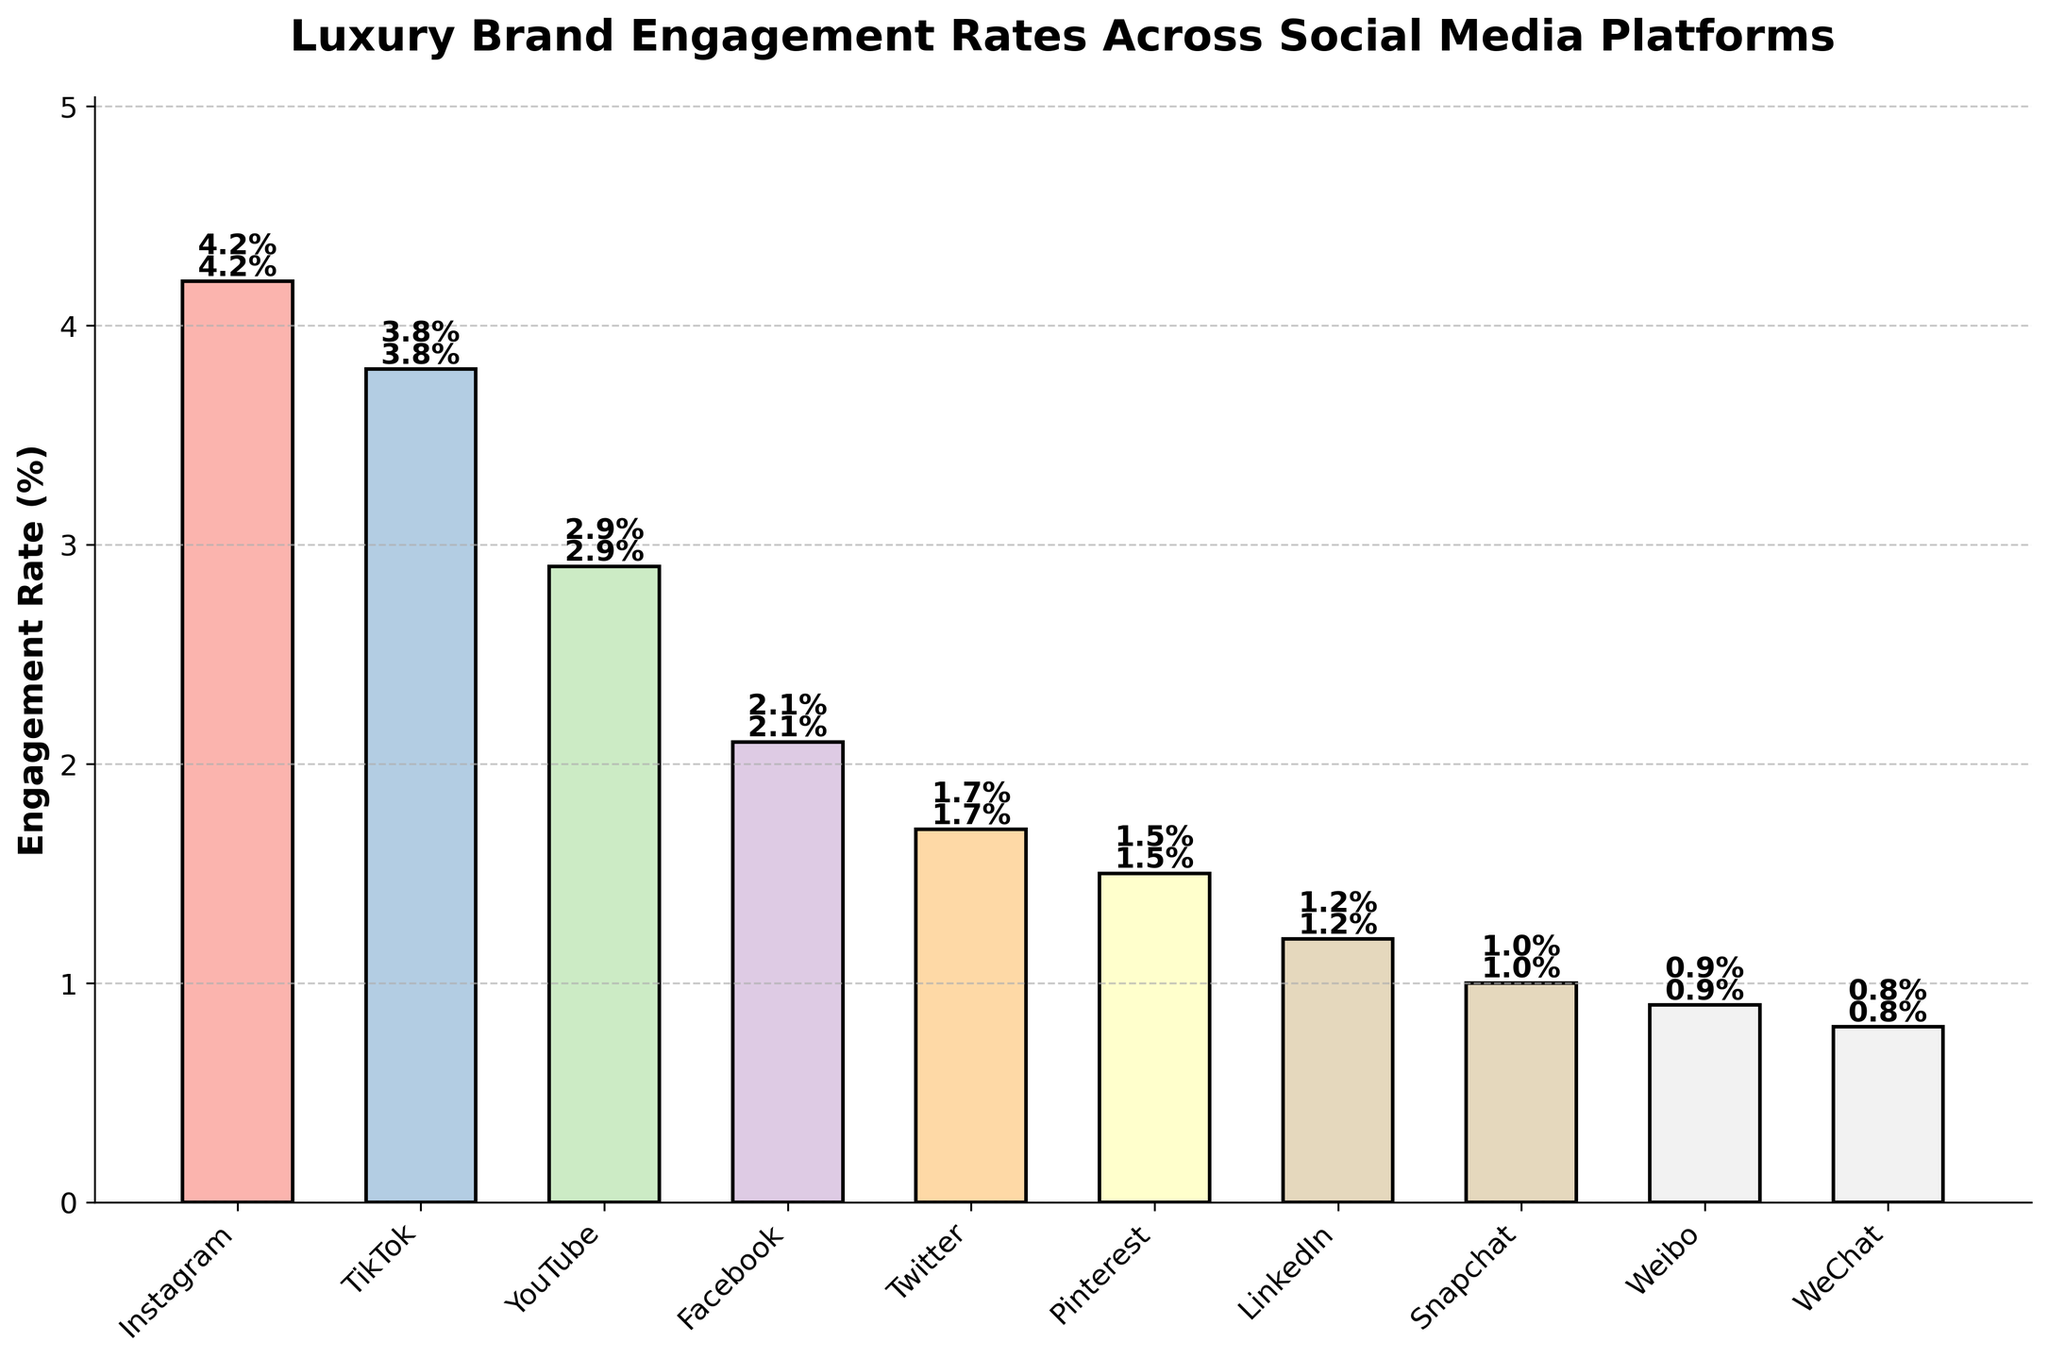What is the average engagement rate across all platforms? To find the average engagement rate, add up the engagement rates of all the platforms and divide by the number of platforms. These rates are 4.2, 3.8, 2.9, 2.1, 1.7, 1.5, 1.2, 1.0, 0.9, and 0.8. Sum them: 4.2 + 3.8 + 2.9 + 2.1 + 1.7 + 1.5 + 1.2 + 1.0 + 0.9 + 0.8 = 20.1. Divide by 10 platforms: 20.1 / 10 = 2.01
Answer: 2.01 Which platform has the highest engagement rate? Look at the bar with the greatest height, which corresponds to the highest engagement rate. The highest bar represents Instagram with an engagement rate of 4.2%.
Answer: Instagram How much higher is TikTok's engagement rate compared to YouTube's? Find TikTok and YouTube's engagement rates and calculate the difference. TikTok's rate is 3.8% and YouTube's is 2.9%. Subtract these values: 3.8 - 2.9 = 0.9. Thus, TikTok's engagement rate is 0.9% higher than YouTube's.
Answer: 0.9 Which platforms have engagement rates less than 2%? Identify all platform bars below the 2% mark. The platforms are Twitter (1.7%), Pinterest (1.5%), LinkedIn (1.2%), Snapchat (1.0%), Weibo (0.9%), and WeChat (0.8%).
Answer: Twitter, Pinterest, LinkedIn, Snapchat, Weibo, WeChat What is the difference in engagement rates between Instagram and Facebook? Find the engagement rates for Instagram and Facebook, and compute the difference. Instagram has an engagement rate of 4.2%, and Facebook has 2.1%. Subtract these rates: 4.2 - 2.1 = 2.1. The difference is 2.1%.
Answer: 2.1 Arrange the platforms in descending order of their engagement rates. List the platforms based on the height of the bars from tallest to shortest: Instagram (4.2%), TikTok (3.8%), YouTube (2.9%), Facebook (2.1%), Twitter (1.7%), Pinterest (1.5%), LinkedIn (1.2%), Snapchat (1.0%), Weibo (0.9%), and WeChat (0.8%).
Answer: Instagram, TikTok, YouTube, Facebook, Twitter, Pinterest, LinkedIn, Snapchat, Weibo, WeChat What is the combined engagement rate of the top three platforms? Identify the engagement rates of Instagram (4.2%), TikTok (3.8%), and YouTube (2.9%). Sum these rates: 4.2 + 3.8 + 2.9 = 10.9. The total engagement rate for the top three platforms is 10.9%.
Answer: 10.9 By how much does the engagement rate of Pinterest lag behind Twitter? Look at the engagement rates of Pinterest (1.5%) and Twitter (1.7%), and find the difference: 1.7 - 1.5 = 0.2. Pinterest lags behind Twitter by 0.2%.
Answer: 0.2 Which platform has the lowest engagement rate, and what is it? Identify the shortest bar, which corresponds to the lowest engagement rate. The lowest is WeChat with an engagement rate of 0.8%.
Answer: WeChat, 0.8 Compare the engagement rates of Snapchat and LinkedIn. Which one is higher and by how much? Locate the bars for Snapchat (1.0%) and LinkedIn (1.2%). Determine the difference: 1.2 - 1.0 = 0.2. LinkedIn's engagement rate is higher by 0.2%.
Answer: LinkedIn, 0.2 